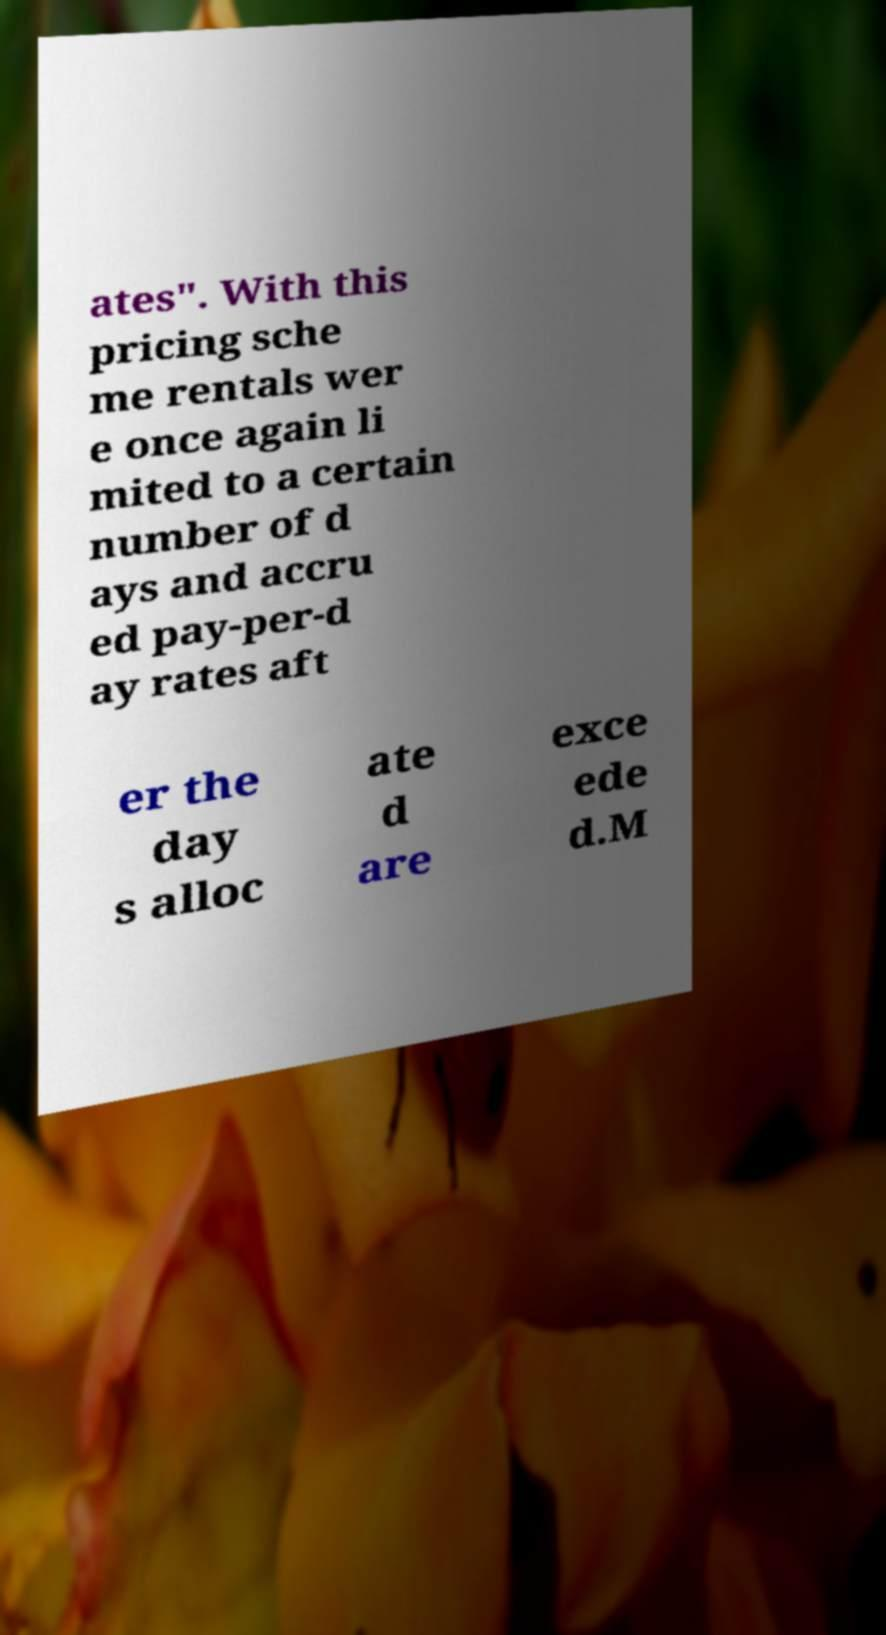Could you assist in decoding the text presented in this image and type it out clearly? ates". With this pricing sche me rentals wer e once again li mited to a certain number of d ays and accru ed pay-per-d ay rates aft er the day s alloc ate d are exce ede d.M 